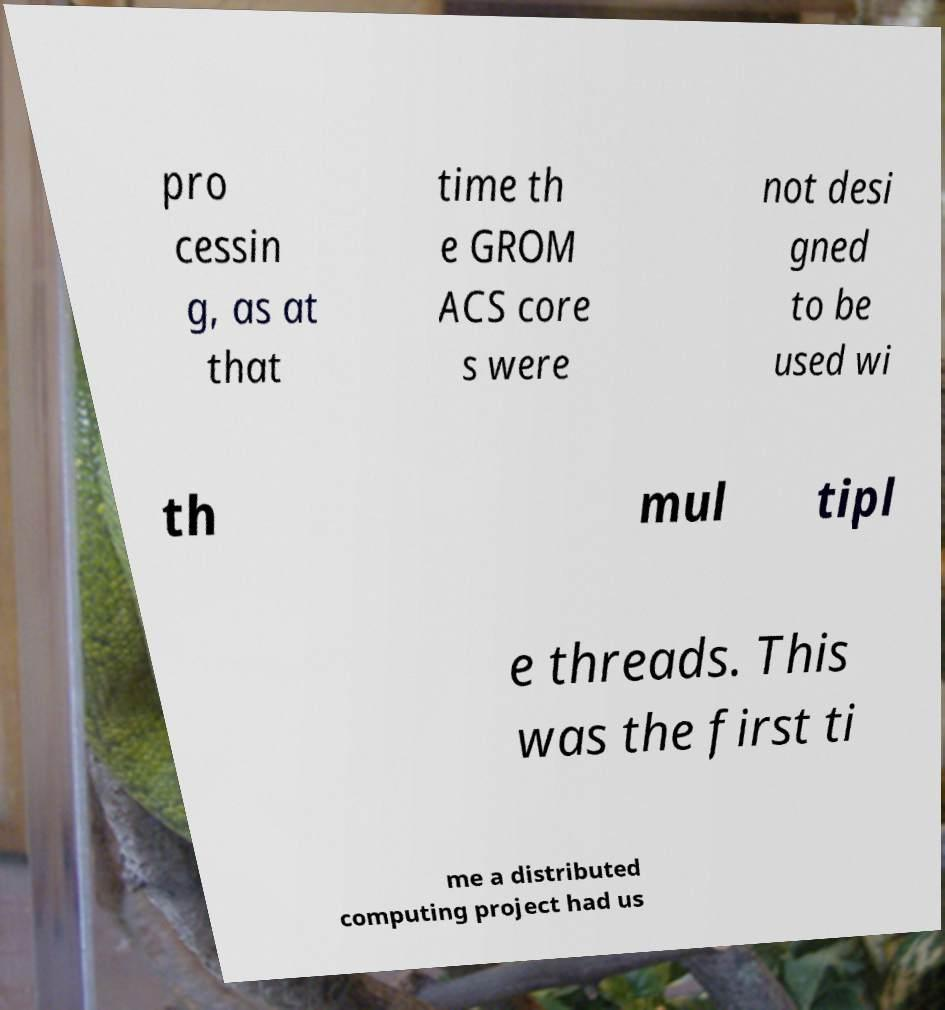Can you accurately transcribe the text from the provided image for me? pro cessin g, as at that time th e GROM ACS core s were not desi gned to be used wi th mul tipl e threads. This was the first ti me a distributed computing project had us 